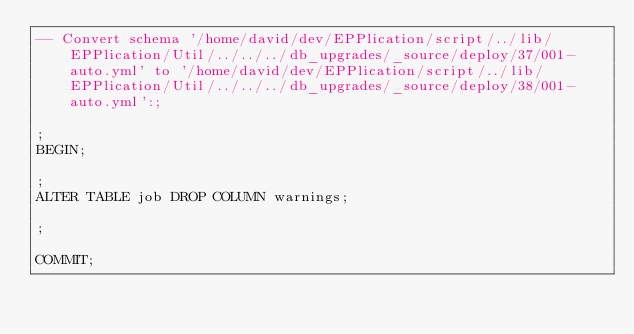<code> <loc_0><loc_0><loc_500><loc_500><_SQL_>-- Convert schema '/home/david/dev/EPPlication/script/../lib/EPPlication/Util/../../../db_upgrades/_source/deploy/37/001-auto.yml' to '/home/david/dev/EPPlication/script/../lib/EPPlication/Util/../../../db_upgrades/_source/deploy/38/001-auto.yml':;

;
BEGIN;

;
ALTER TABLE job DROP COLUMN warnings;

;

COMMIT;

</code> 